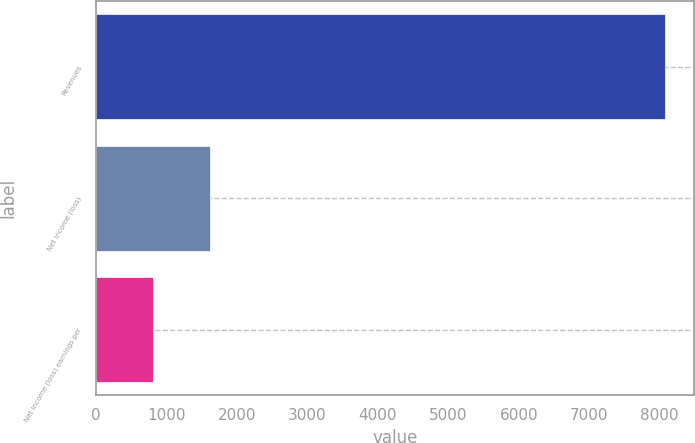Convert chart to OTSL. <chart><loc_0><loc_0><loc_500><loc_500><bar_chart><fcel>Revenues<fcel>Net income (loss)<fcel>Net income (loss) earnings per<nl><fcel>8081<fcel>1617.15<fcel>809.17<nl></chart> 